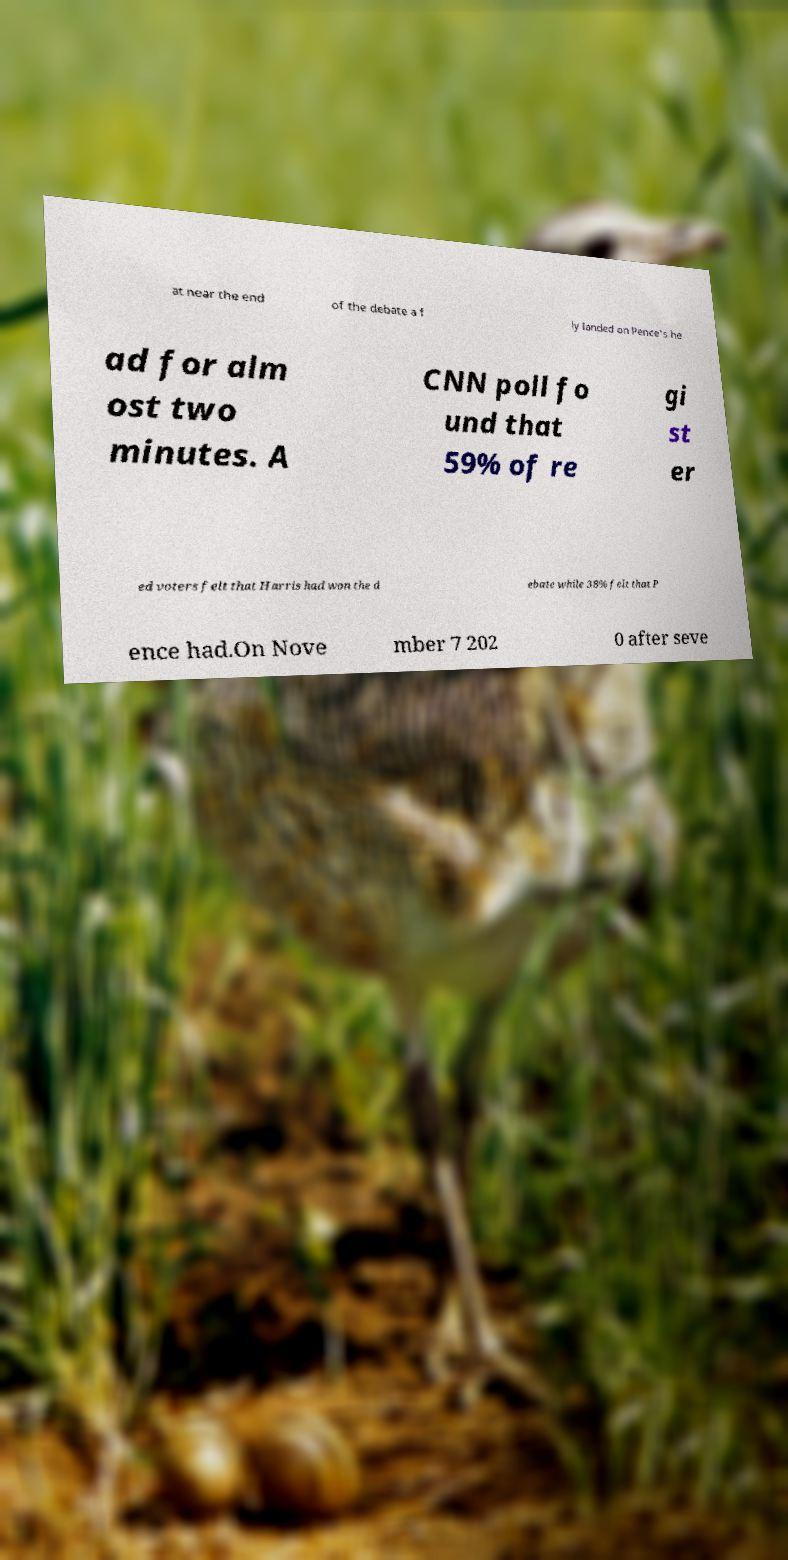What messages or text are displayed in this image? I need them in a readable, typed format. at near the end of the debate a f ly landed on Pence's he ad for alm ost two minutes. A CNN poll fo und that 59% of re gi st er ed voters felt that Harris had won the d ebate while 38% felt that P ence had.On Nove mber 7 202 0 after seve 